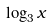Convert formula to latex. <formula><loc_0><loc_0><loc_500><loc_500>\log _ { 3 } x</formula> 